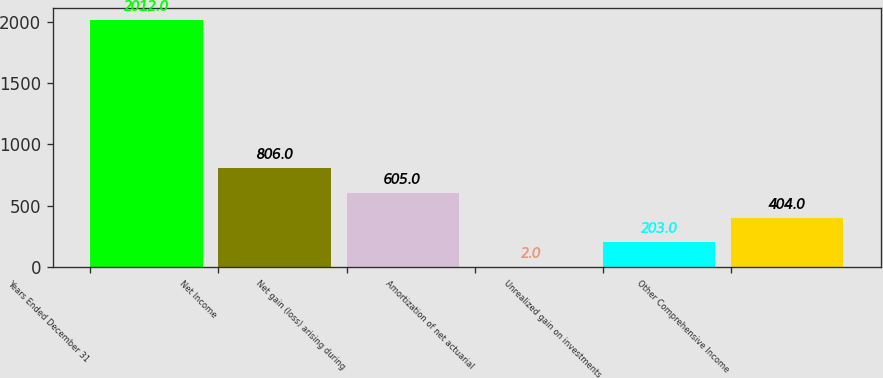Convert chart. <chart><loc_0><loc_0><loc_500><loc_500><bar_chart><fcel>Years Ended December 31<fcel>Net Income<fcel>Net gain (loss) arising during<fcel>Amortization of net actuarial<fcel>Unrealized gain on investments<fcel>Other Comprehensive Income<nl><fcel>2012<fcel>806<fcel>605<fcel>2<fcel>203<fcel>404<nl></chart> 